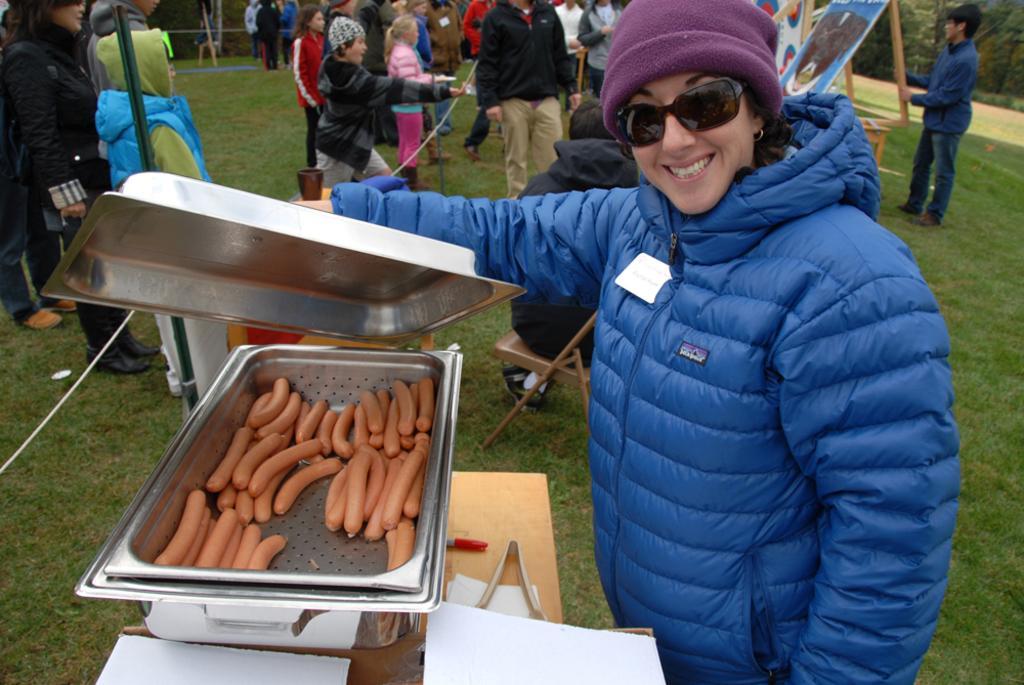Could you give a brief overview of what you see in this image? In this picture we can see a woman wore a cap, goggles, jacket and holding a bowl lid with her hand and in front of her we can see a bowl with sausages in it, tong, papers, pen on a wooden surface and in the background we can see a group of people on the grass, chair, boards, trees and some objects. 